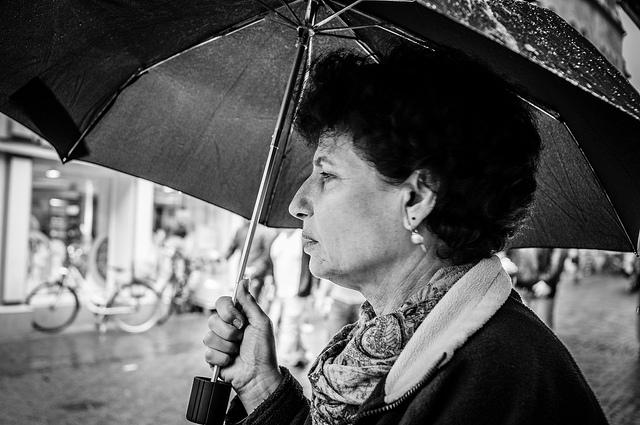What kind of weather is the woman experiencing? Please explain your reasoning. rain. The woman is under an umbrella and their is water around her which points to rain coming down. 